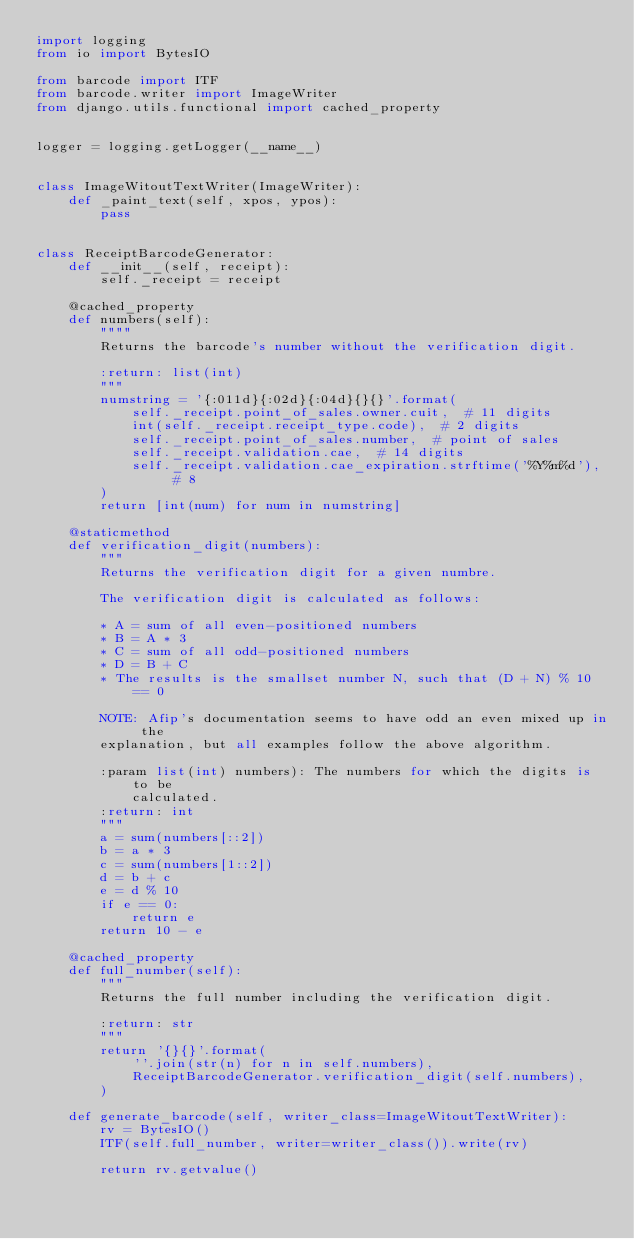Convert code to text. <code><loc_0><loc_0><loc_500><loc_500><_Python_>import logging
from io import BytesIO

from barcode import ITF
from barcode.writer import ImageWriter
from django.utils.functional import cached_property


logger = logging.getLogger(__name__)


class ImageWitoutTextWriter(ImageWriter):
    def _paint_text(self, xpos, ypos):
        pass


class ReceiptBarcodeGenerator:
    def __init__(self, receipt):
        self._receipt = receipt

    @cached_property
    def numbers(self):
        """"
        Returns the barcode's number without the verification digit.

        :return: list(int)
        """
        numstring = '{:011d}{:02d}{:04d}{}{}'.format(
            self._receipt.point_of_sales.owner.cuit,  # 11 digits
            int(self._receipt.receipt_type.code),  # 2 digits
            self._receipt.point_of_sales.number,  # point of sales
            self._receipt.validation.cae,  # 14 digits
            self._receipt.validation.cae_expiration.strftime('%Y%m%d'),  # 8
        )
        return [int(num) for num in numstring]

    @staticmethod
    def verification_digit(numbers):
        """
        Returns the verification digit for a given numbre.

        The verification digit is calculated as follows:

        * A = sum of all even-positioned numbers
        * B = A * 3
        * C = sum of all odd-positioned numbers
        * D = B + C
        * The results is the smallset number N, such that (D + N) % 10 == 0

        NOTE: Afip's documentation seems to have odd an even mixed up in the
        explanation, but all examples follow the above algorithm.

        :param list(int) numbers): The numbers for which the digits is to be
            calculated.
        :return: int
        """
        a = sum(numbers[::2])
        b = a * 3
        c = sum(numbers[1::2])
        d = b + c
        e = d % 10
        if e == 0:
            return e
        return 10 - e

    @cached_property
    def full_number(self):
        """
        Returns the full number including the verification digit.

        :return: str
        """
        return '{}{}'.format(
            ''.join(str(n) for n in self.numbers),
            ReceiptBarcodeGenerator.verification_digit(self.numbers),
        )

    def generate_barcode(self, writer_class=ImageWitoutTextWriter):
        rv = BytesIO()
        ITF(self.full_number, writer=writer_class()).write(rv)

        return rv.getvalue()
</code> 